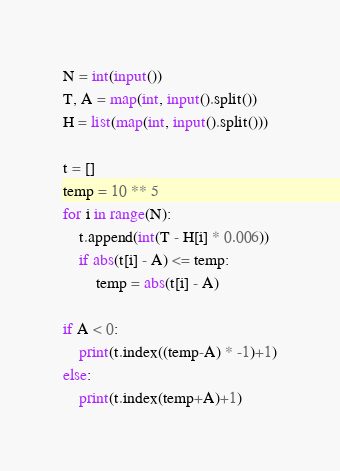<code> <loc_0><loc_0><loc_500><loc_500><_Python_>N = int(input())
T, A = map(int, input().split())
H = list(map(int, input().split()))

t = []
temp = 10 ** 5
for i in range(N):
    t.append(int(T - H[i] * 0.006))
    if abs(t[i] - A) <= temp:
        temp = abs(t[i] - A)

if A < 0:
    print(t.index((temp-A) * -1)+1)
else:
    print(t.index(temp+A)+1)
</code> 